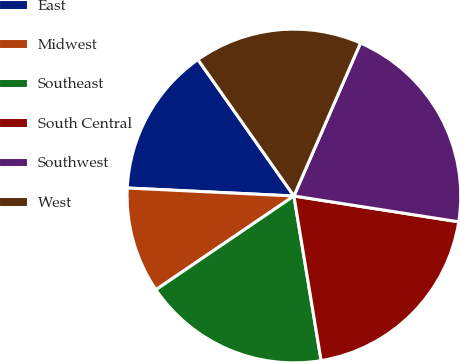Convert chart to OTSL. <chart><loc_0><loc_0><loc_500><loc_500><pie_chart><fcel>East<fcel>Midwest<fcel>Southeast<fcel>South Central<fcel>Southwest<fcel>West<nl><fcel>14.48%<fcel>10.26%<fcel>18.11%<fcel>19.92%<fcel>20.94%<fcel>16.29%<nl></chart> 